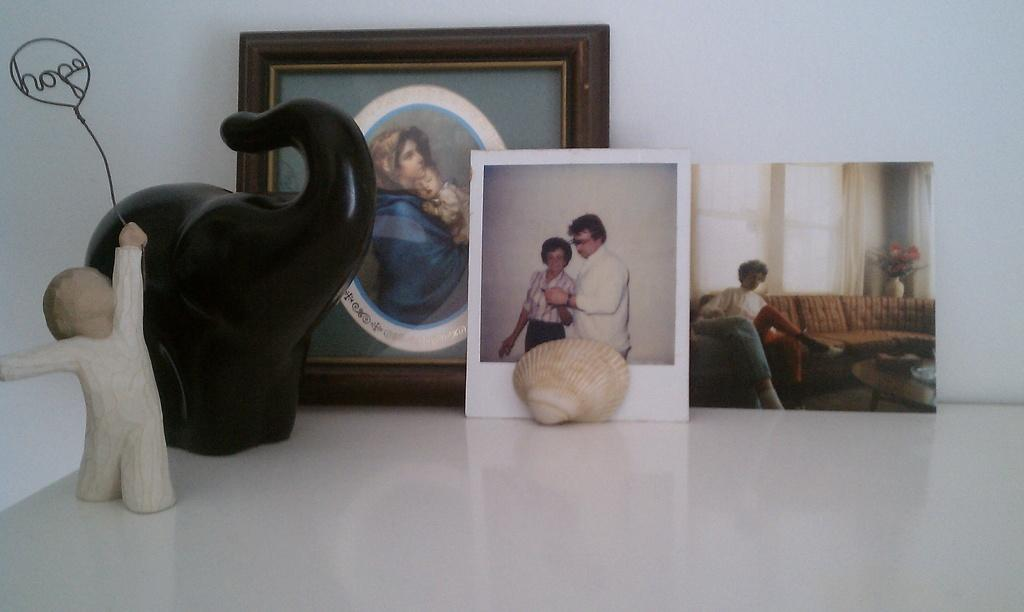What type of objects are grouped together in the image? There is a group of photos in the image. What other object can be seen in the image? There is a shell in the image. Are there any other notable objects in the image? Yes, there are two sculptures in the image. Where are these objects placed? The objects are placed on a table. What type of clam is used as a decoration in the image? There is no clam present in the image; it features a shell, but not a clam. How many days of the week are visible in the image? There is no reference to days of the week in the image. 